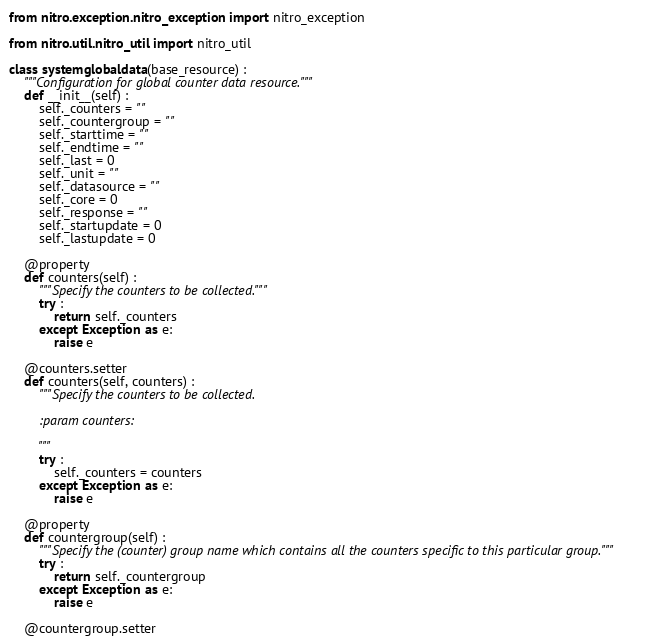Convert code to text. <code><loc_0><loc_0><loc_500><loc_500><_Python_>from nitro.exception.nitro_exception import nitro_exception

from nitro.util.nitro_util import nitro_util

class systemglobaldata(base_resource) :
    """Configuration for global counter data resource."""
    def __init__(self) :
        self._counters = ""
        self._countergroup = ""
        self._starttime = ""
        self._endtime = ""
        self._last = 0
        self._unit = ""
        self._datasource = ""
        self._core = 0
        self._response = ""
        self._startupdate = 0
        self._lastupdate = 0

    @property
    def counters(self) :
        """Specify the counters to be collected."""
        try :
            return self._counters
        except Exception as e:
            raise e

    @counters.setter
    def counters(self, counters) :
        """Specify the counters to be collected.

        :param counters: 

        """
        try :
            self._counters = counters
        except Exception as e:
            raise e

    @property
    def countergroup(self) :
        """Specify the (counter) group name which contains all the counters specific to this particular group."""
        try :
            return self._countergroup
        except Exception as e:
            raise e

    @countergroup.setter</code> 